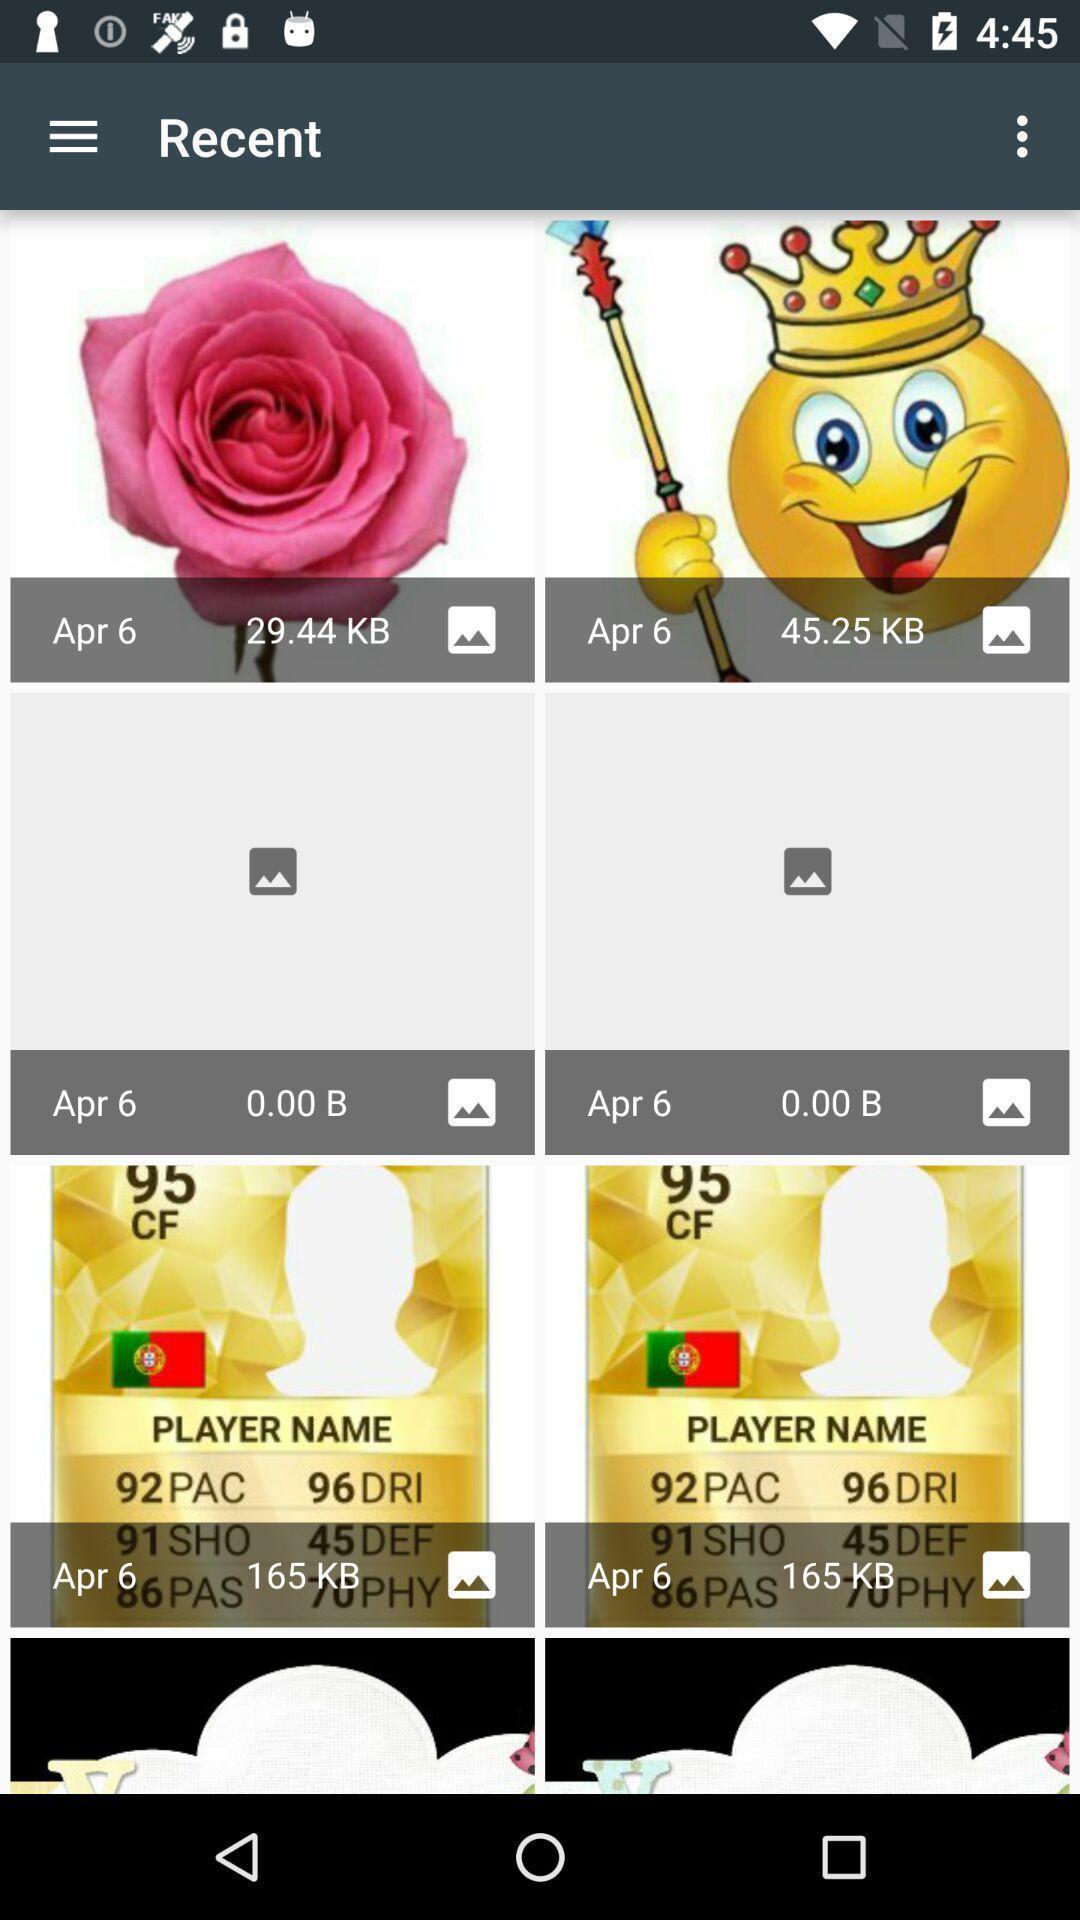Describe the key features of this screenshot. Screen shows recent images. 